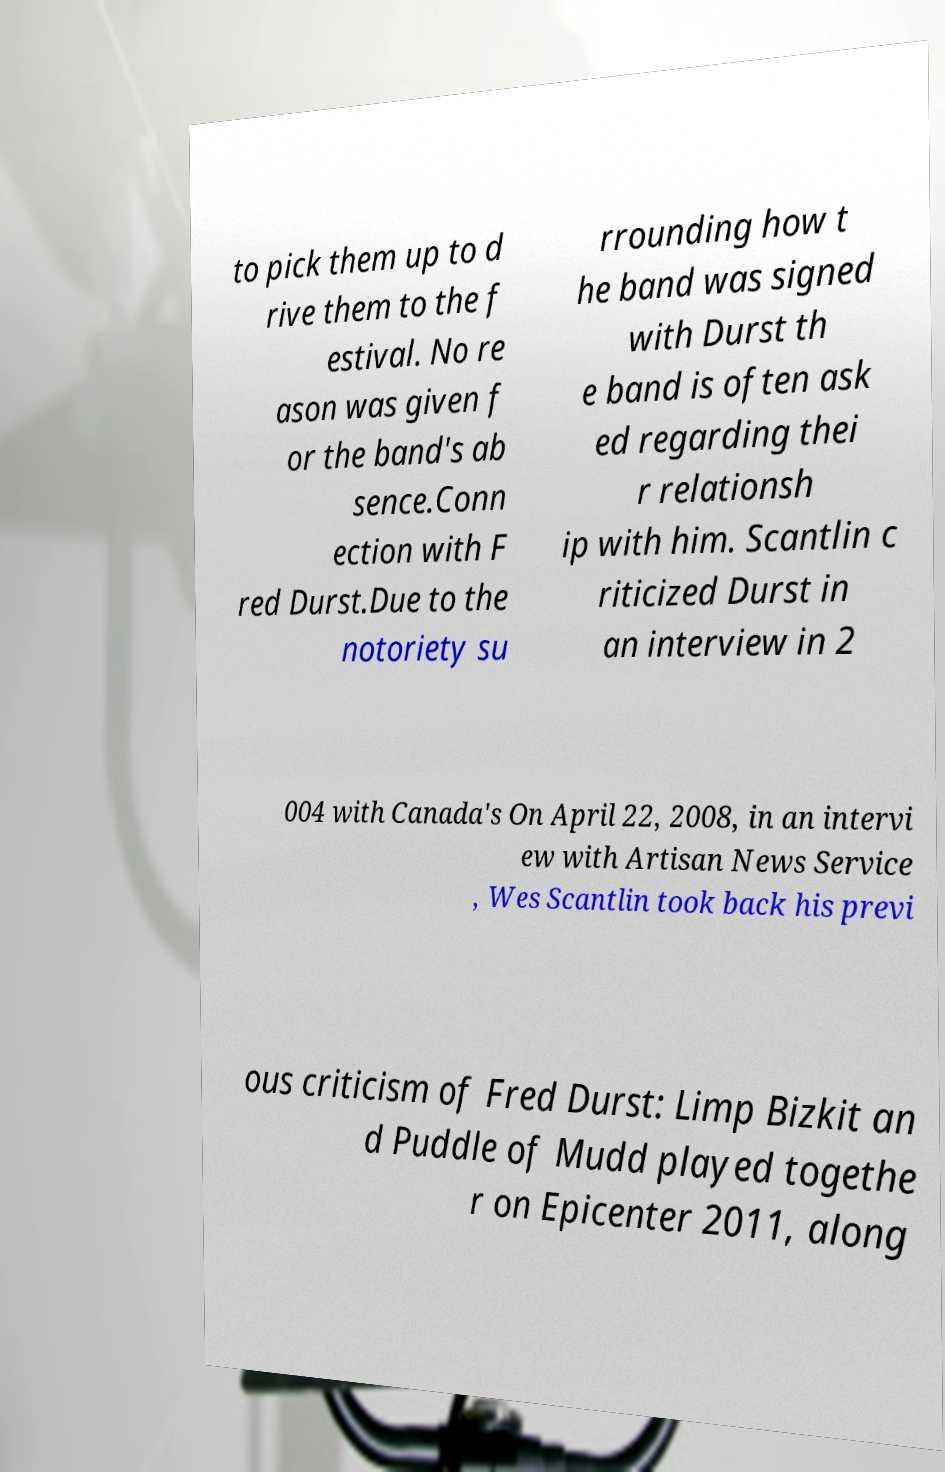What messages or text are displayed in this image? I need them in a readable, typed format. to pick them up to d rive them to the f estival. No re ason was given f or the band's ab sence.Conn ection with F red Durst.Due to the notoriety su rrounding how t he band was signed with Durst th e band is often ask ed regarding thei r relationsh ip with him. Scantlin c riticized Durst in an interview in 2 004 with Canada's On April 22, 2008, in an intervi ew with Artisan News Service , Wes Scantlin took back his previ ous criticism of Fred Durst: Limp Bizkit an d Puddle of Mudd played togethe r on Epicenter 2011, along 